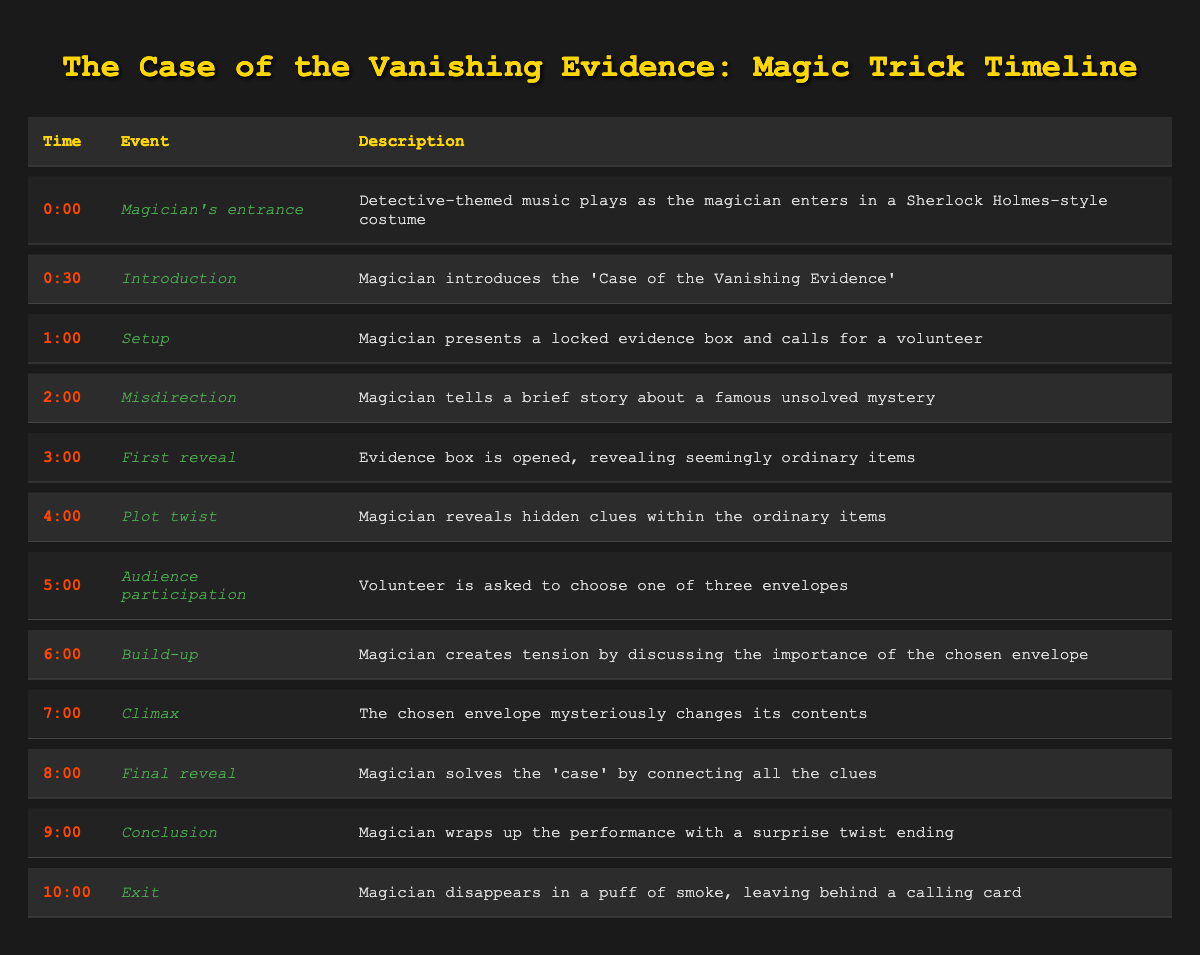What event takes place at 2:00? The event listed at 2:00 is "Misdirection," and the description states that the magician tells a brief story about a famous unsolved mystery.
Answer: Misdirection What is the climax of the performance? The climax of the performance listed at 7:00 is when "The chosen envelope mysteriously changes its contents."
Answer: The chosen envelope mysteriously changes its contents Did the magician make a specific reveal at 4:00? Yes, at 4:00 during the "Plot twist" event, the magician reveals hidden clues within the ordinary items.
Answer: Yes At what time does the magician introduce the case? The magician introduces the case at 0:30, as indicated in the "Introduction" event.
Answer: 0:30 How many minutes are there between the magician's entrance and the final reveal? The entrance occurs at 0:00 and the final reveal occurs at 8:00. The time difference is 8 minutes (8:00 - 0:00).
Answer: 8 minutes Is there audience participation involved in the performance? Yes, audience participation is included, specifically at 5:00 when the volunteer is asked to choose one of three envelopes.
Answer: Yes What is the final event of the magic performance? The final event of the performance is the "Exit" at 10:00, where the magician disappears in a puff of smoke, leaving behind a calling card.
Answer: Exit How many total events are listed in the performance timeline? There are 11 total events listed in the performance timeline. This includes all events from the magician's entrance to the exit.
Answer: 11 events What happens immediately before the conclusion? The event immediately before the conclusion at 9:00 is the "Final reveal" at 8:00, where the magician solves the 'case' by connecting all the clues.
Answer: Final reveal 